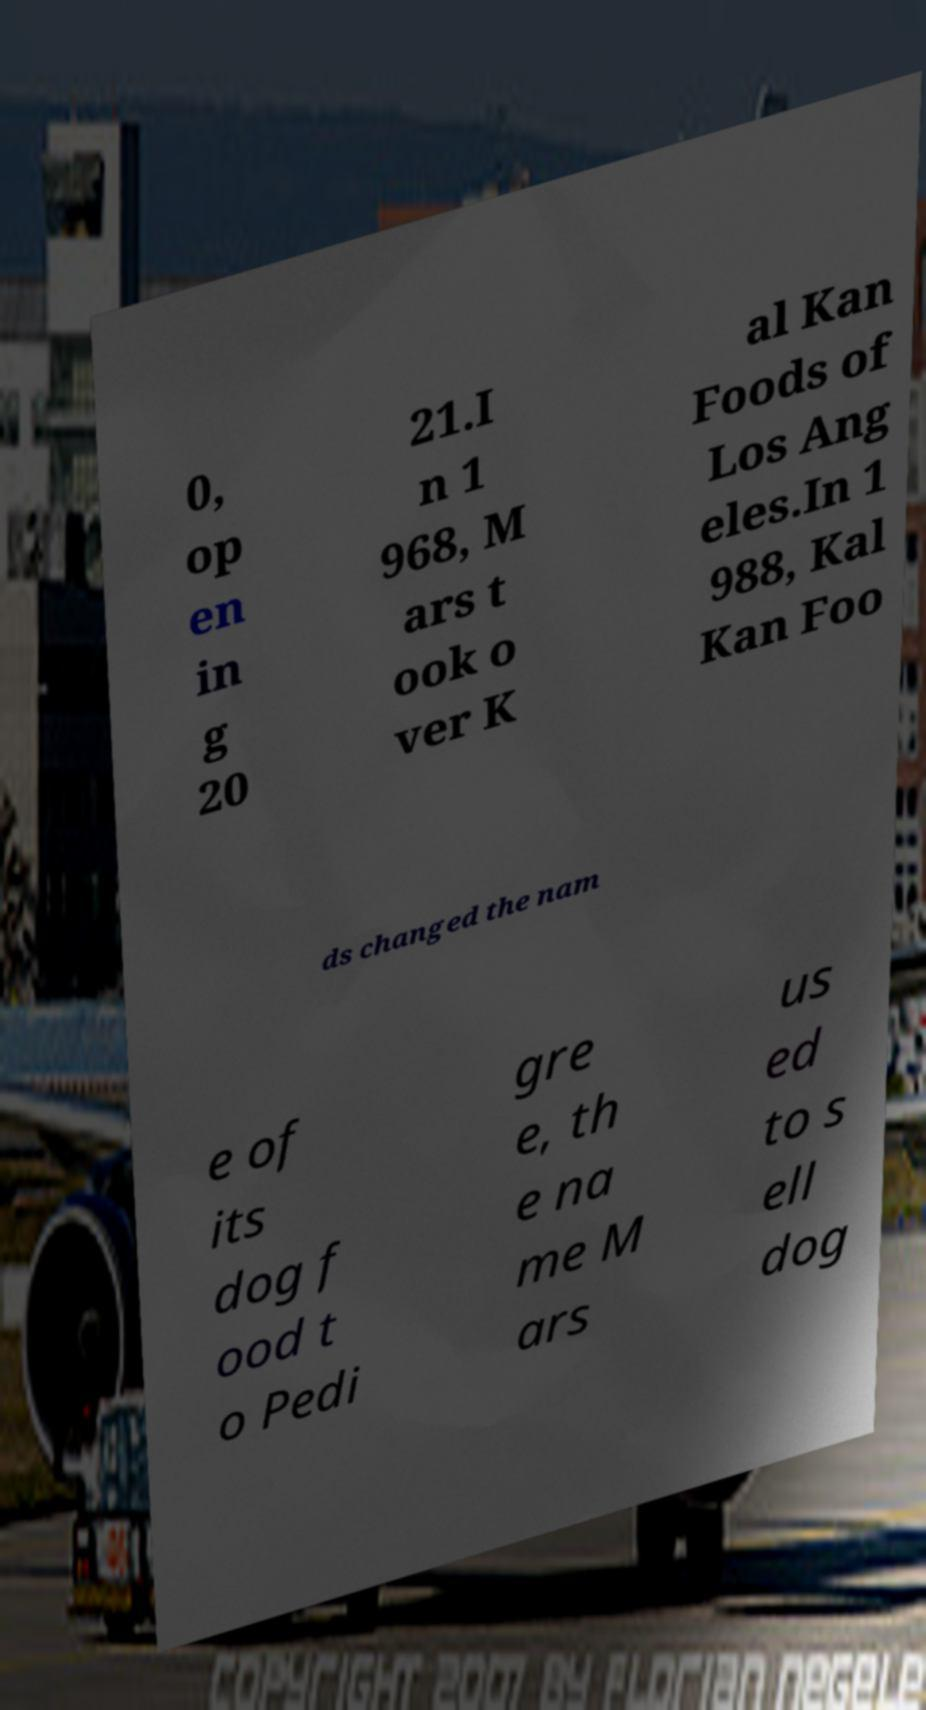What messages or text are displayed in this image? I need them in a readable, typed format. 0, op en in g 20 21.I n 1 968, M ars t ook o ver K al Kan Foods of Los Ang eles.In 1 988, Kal Kan Foo ds changed the nam e of its dog f ood t o Pedi gre e, th e na me M ars us ed to s ell dog 